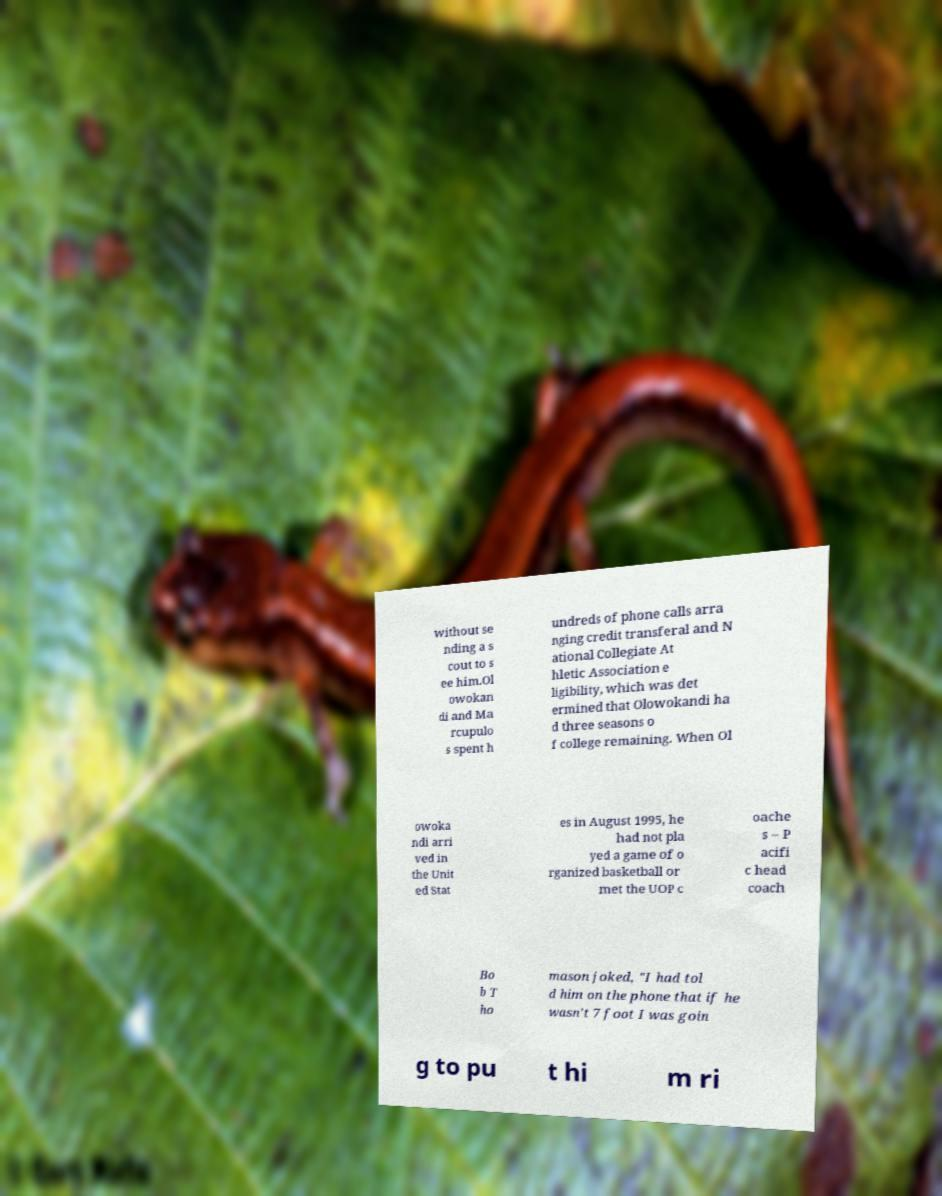Can you read and provide the text displayed in the image?This photo seems to have some interesting text. Can you extract and type it out for me? without se nding a s cout to s ee him.Ol owokan di and Ma rcupulo s spent h undreds of phone calls arra nging credit transferal and N ational Collegiate At hletic Association e ligibility, which was det ermined that Olowokandi ha d three seasons o f college remaining. When Ol owoka ndi arri ved in the Unit ed Stat es in August 1995, he had not pla yed a game of o rganized basketball or met the UOP c oache s – P acifi c head coach Bo b T ho mason joked, "I had tol d him on the phone that if he wasn't 7 foot I was goin g to pu t hi m ri 